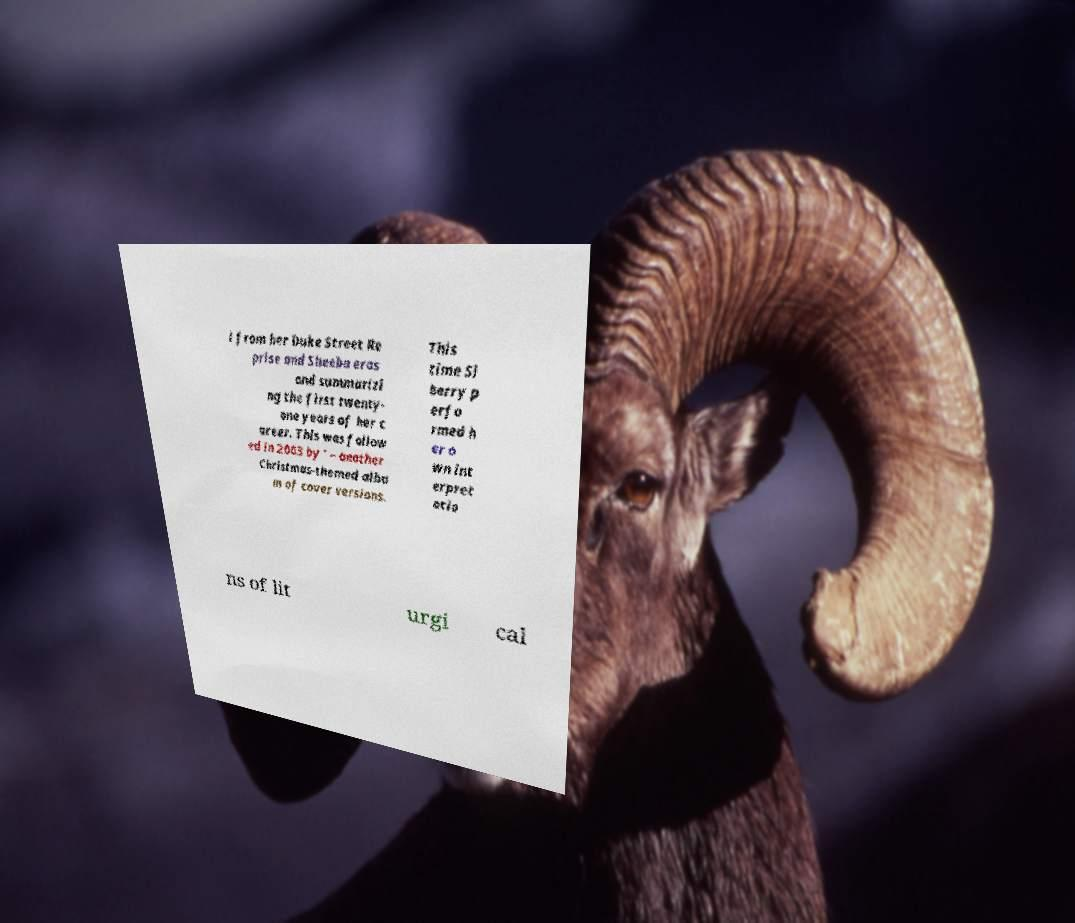There's text embedded in this image that I need extracted. Can you transcribe it verbatim? l from her Duke Street Re prise and Sheeba eras and summarizi ng the first twenty- one years of her c areer. This was follow ed in 2003 by ' – another Christmas-themed albu m of cover versions. This time Si berry p erfo rmed h er o wn int erpret atio ns of lit urgi cal 